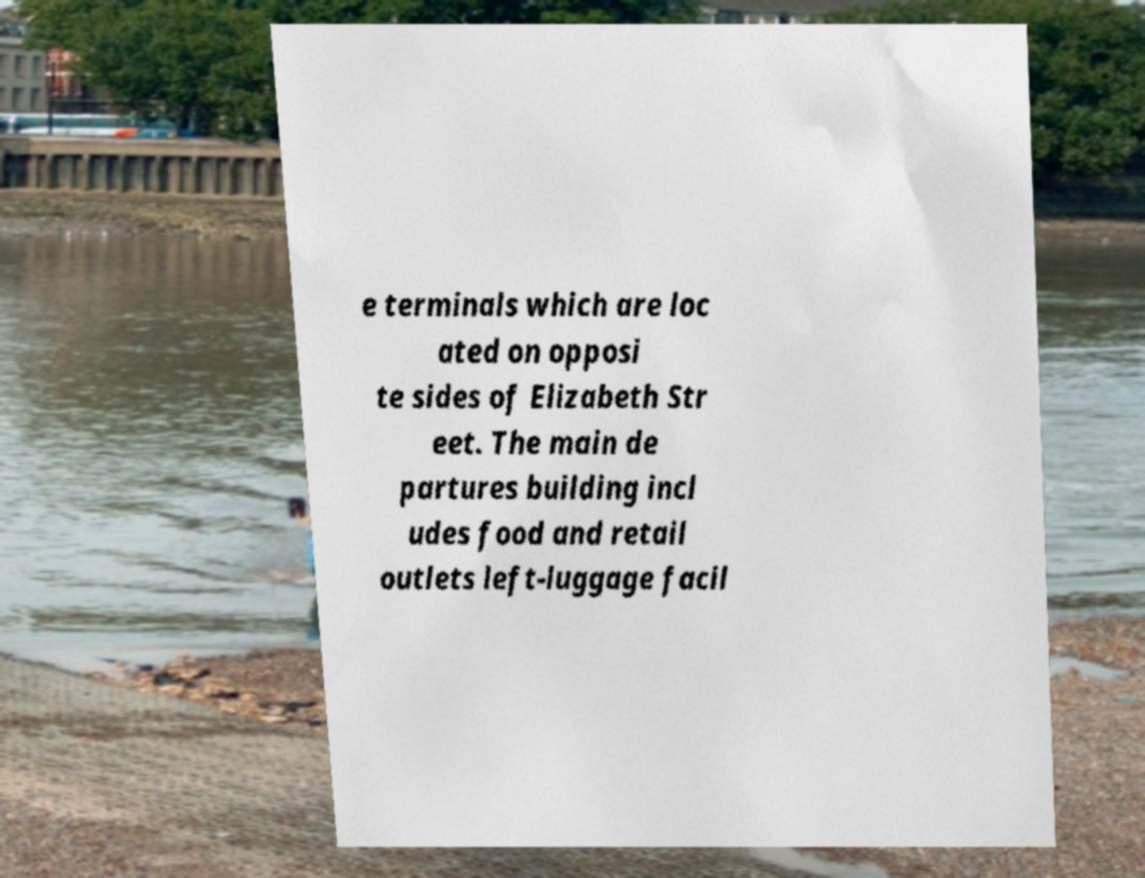Please identify and transcribe the text found in this image. e terminals which are loc ated on opposi te sides of Elizabeth Str eet. The main de partures building incl udes food and retail outlets left-luggage facil 